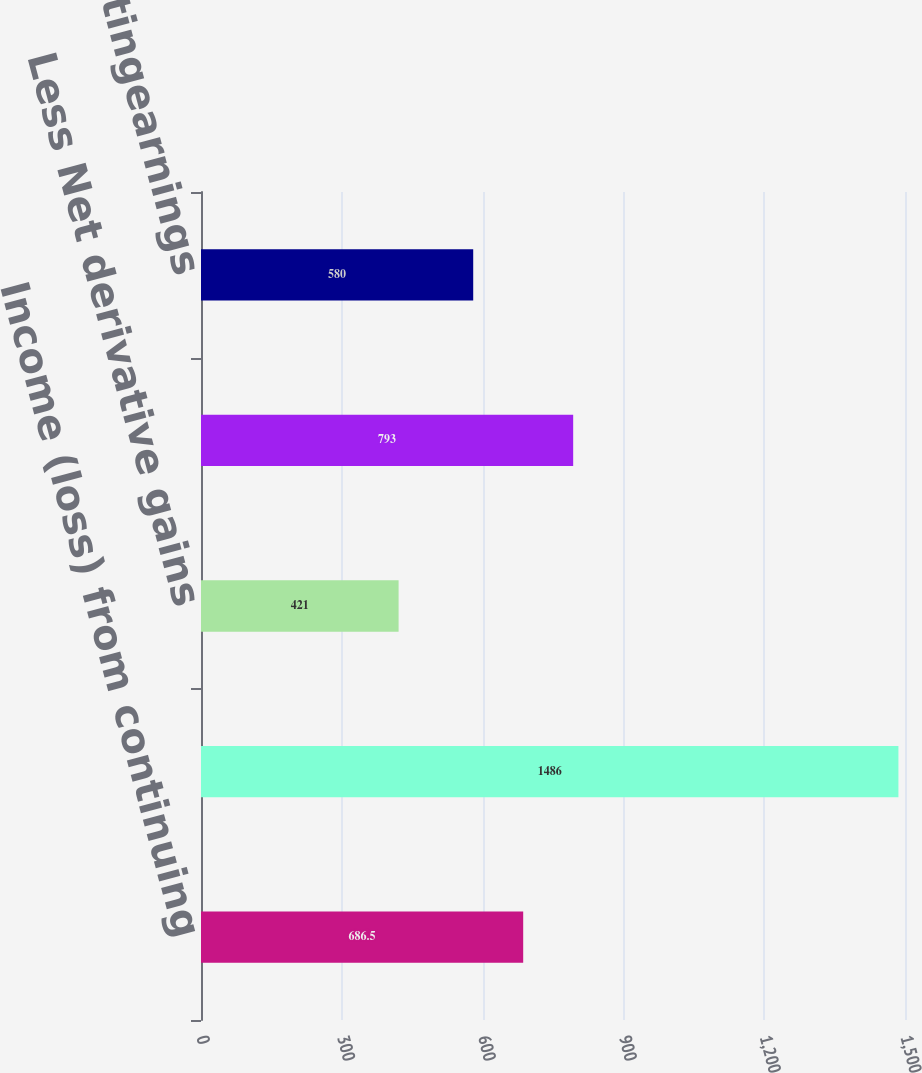Convert chart to OTSL. <chart><loc_0><loc_0><loc_500><loc_500><bar_chart><fcel>Income (loss) from continuing<fcel>Less Net investment gains<fcel>Less Net derivative gains<fcel>Less Provision for income tax<fcel>Operatingearnings<nl><fcel>686.5<fcel>1486<fcel>421<fcel>793<fcel>580<nl></chart> 